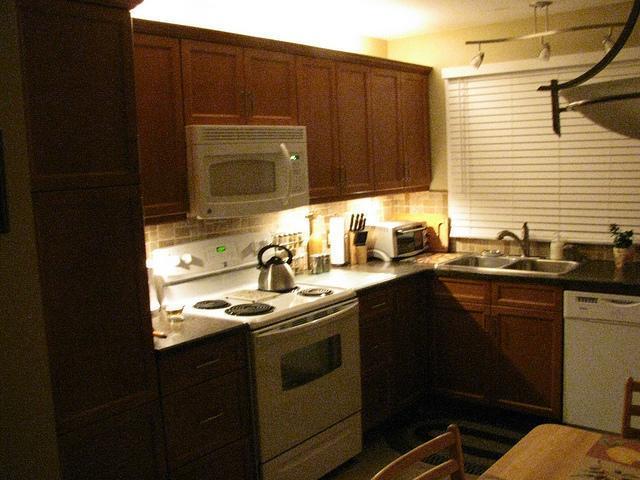How many things are on the stove?
Give a very brief answer. 1. How many ovens are there?
Give a very brief answer. 2. 